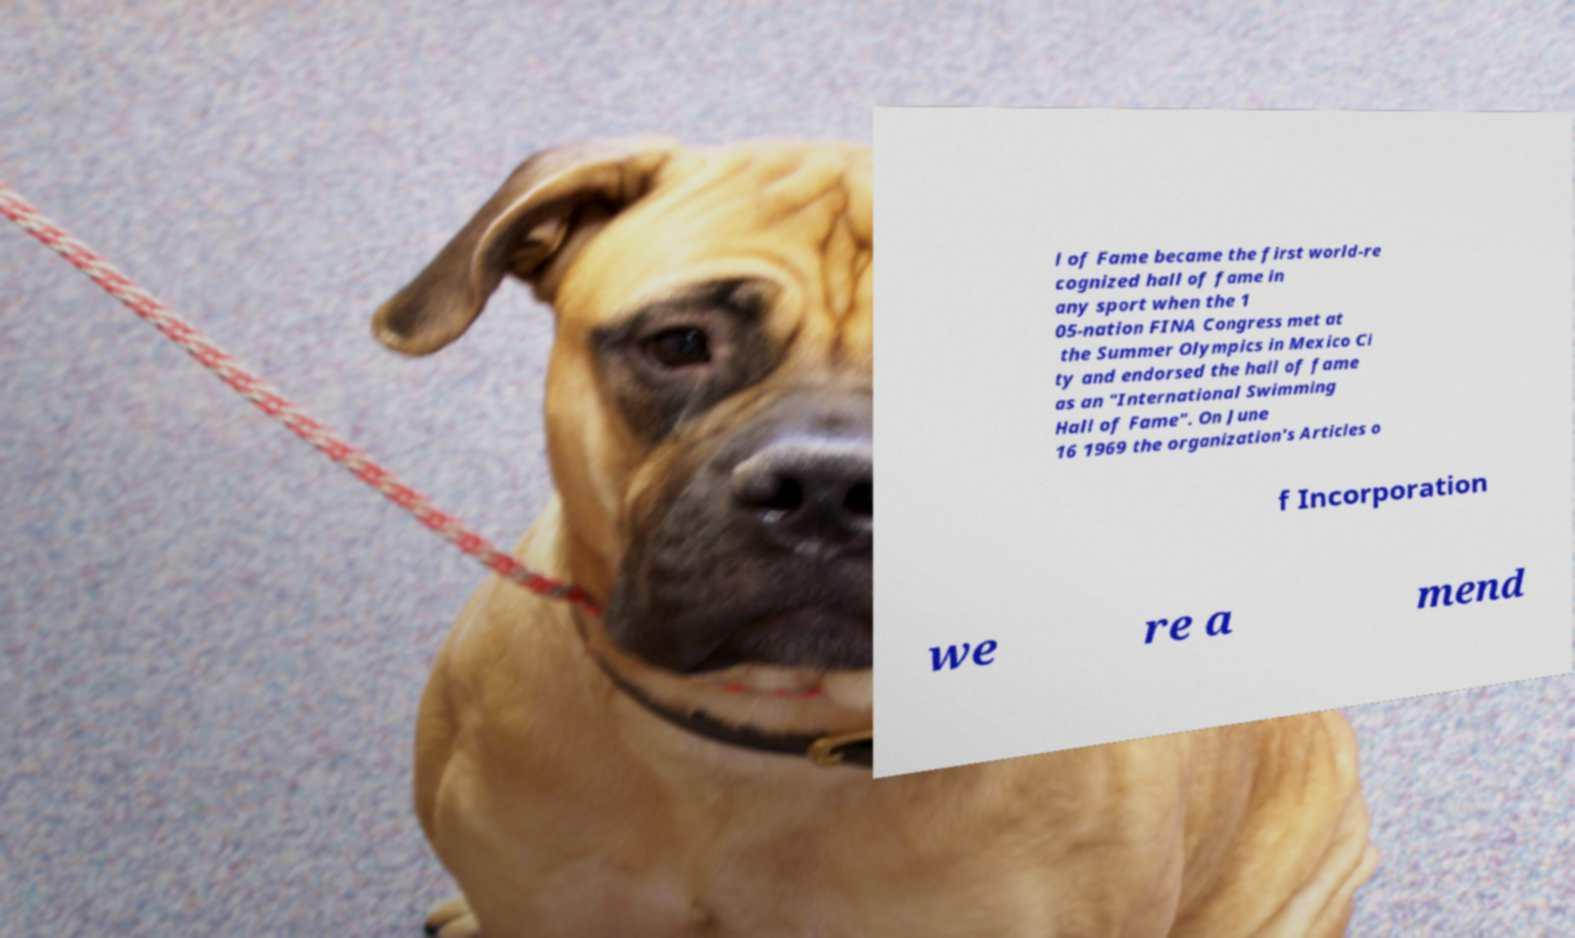Can you accurately transcribe the text from the provided image for me? l of Fame became the first world-re cognized hall of fame in any sport when the 1 05-nation FINA Congress met at the Summer Olympics in Mexico Ci ty and endorsed the hall of fame as an "International Swimming Hall of Fame". On June 16 1969 the organization's Articles o f Incorporation we re a mend 